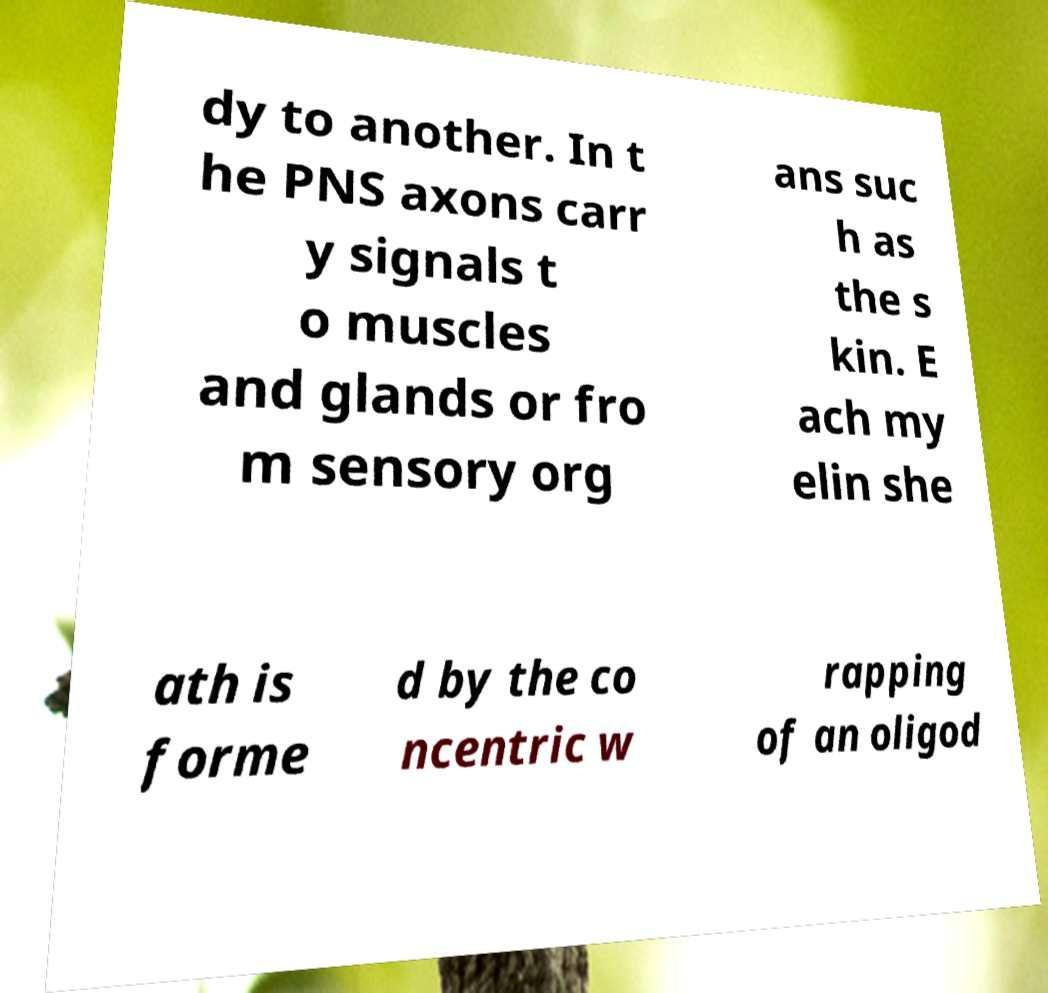Could you assist in decoding the text presented in this image and type it out clearly? dy to another. In t he PNS axons carr y signals t o muscles and glands or fro m sensory org ans suc h as the s kin. E ach my elin she ath is forme d by the co ncentric w rapping of an oligod 